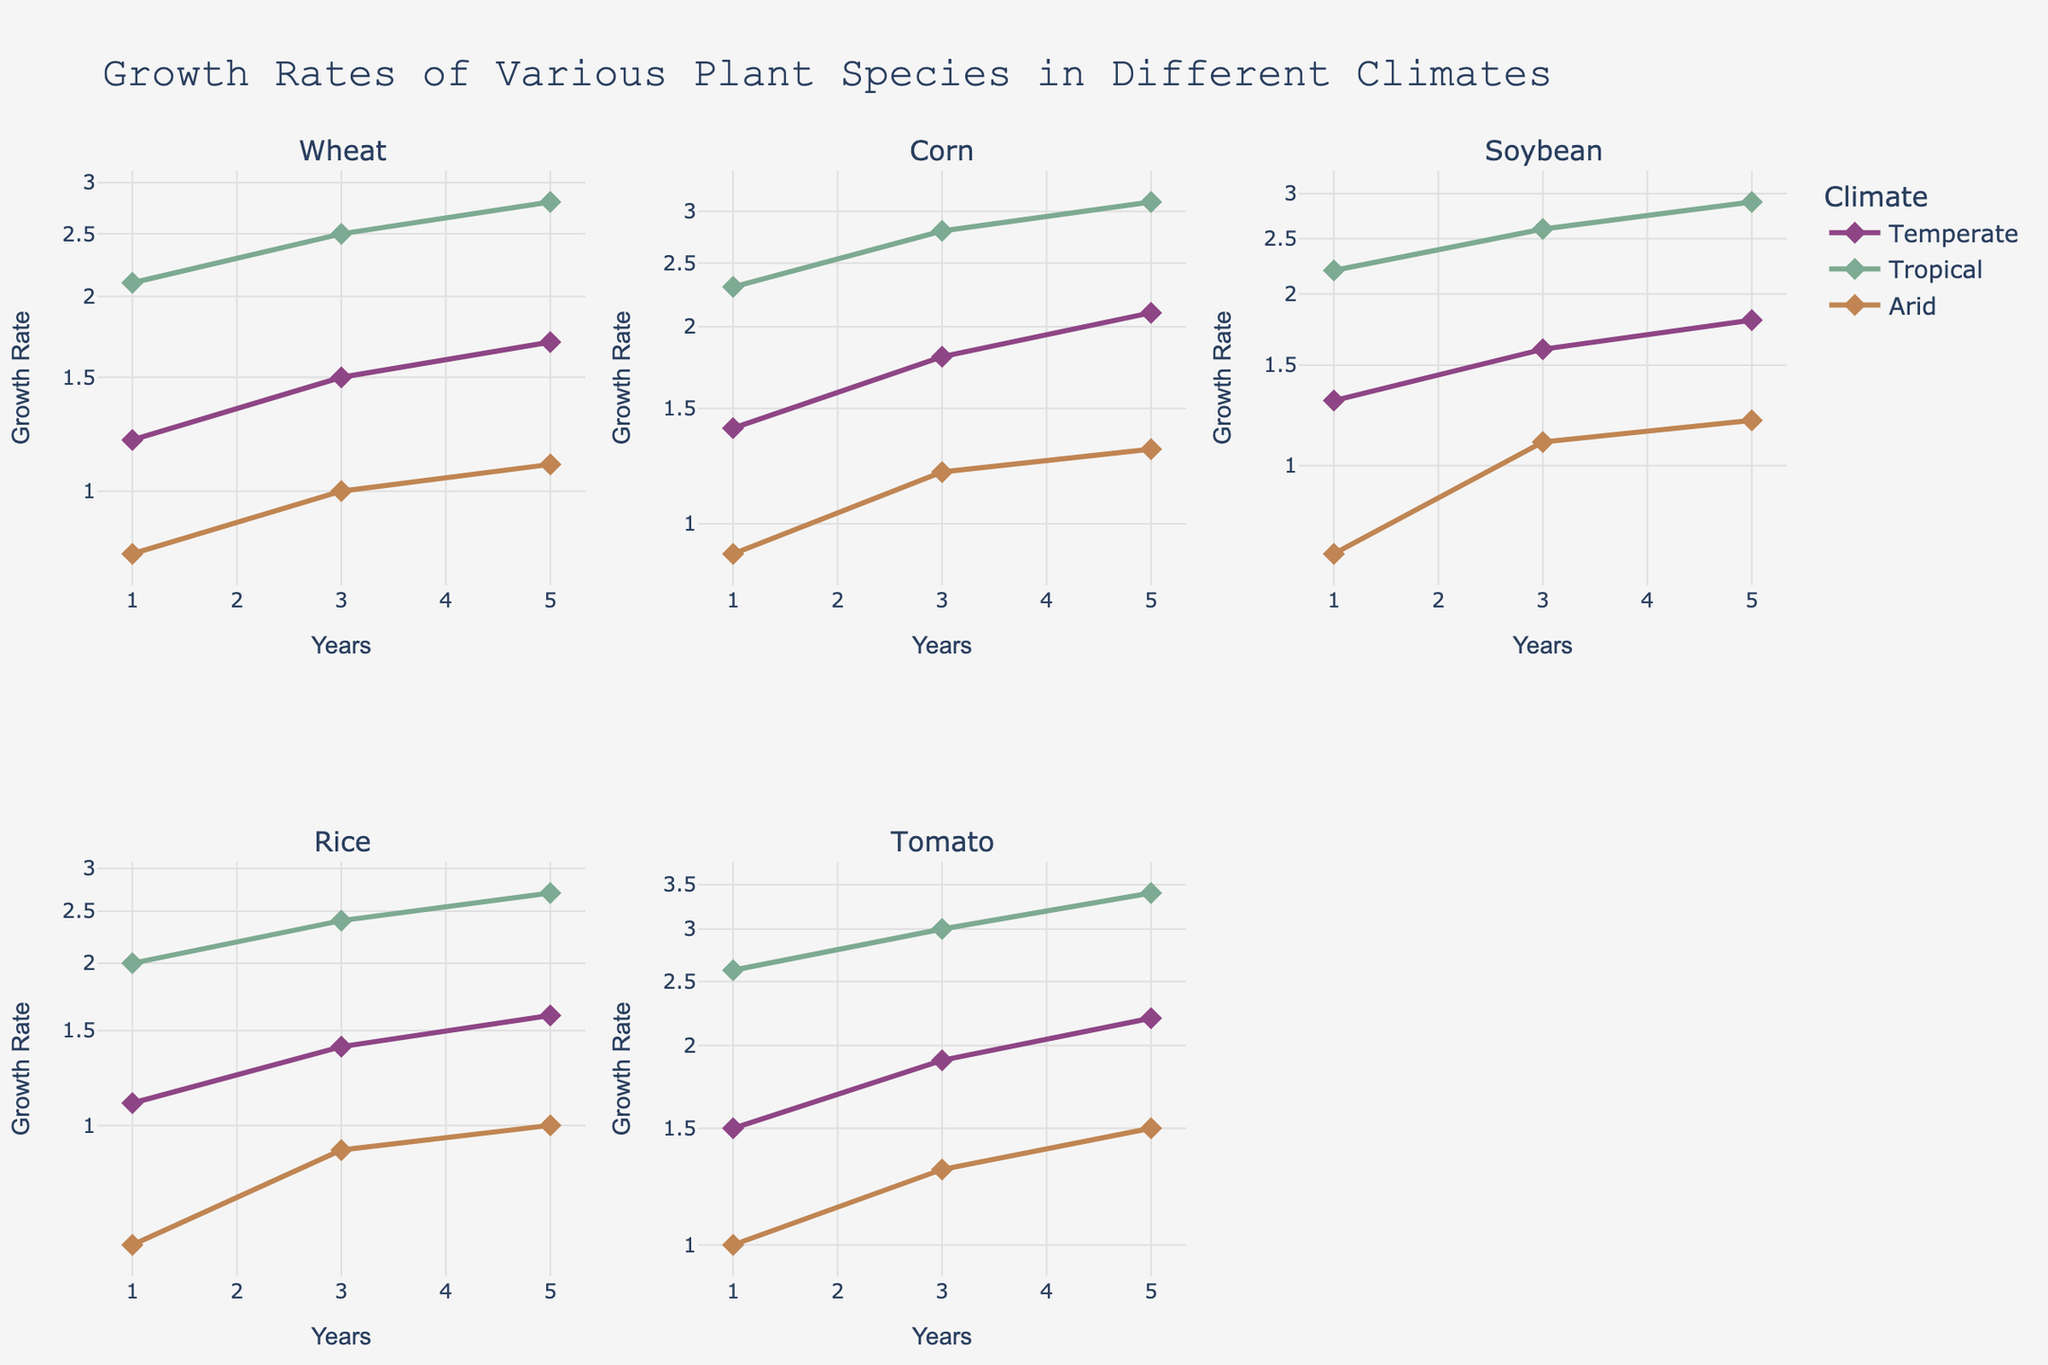What is the title of the figure? The title is usually displayed prominently at the top of the figure; it summarizes the overall content.
Answer: "Growth Rates of Various Plant Species in Different Climates" What are the types of climates represented in the figure? The legend in the figure indicates the different climates represented.
Answer: Temperate, Tropical, Arid Which plant species shows the highest growth rate in a tropical climate at year 5? Check each subplot corresponding to a plant species, look at the data points for year 5, and identify the one with the highest value, focusing on the tropical climate.
Answer: Tomato What is the difference in growth rates of Corn between the tropical and arid climates at year 3? In the subplot for Corn, note the data points for both tropical and arid climates at year 3, then subtract the arid growth rate from the tropical growth rate.
Answer: 1.6 How do the growth rates of Wheat at year 5 in temperate and arid climates compare? In the Wheat subplot, observe the year 5 data points for both temperate and arid climates and compare their values.
Answer: Temperate is higher What is the primary pattern you observe for plant species in tropical climates? Observing the subplots for each plant species, note the trend in growth rates across the years for the tropical climate.
Answer: Highest growth rates Which climate shows the lowest growth rates generally across all plants? Look at the overall trend in each subplot, focusing on the lowest values across different climates for all plants.
Answer: Arid What is the average growth rate of Rice in a temperate climate across all years? Find the growth rates for Rice in a temperate climate at years 1, 3, and 5, add them together and divide by 3.
Answer: 1.37 How does the growth rate trend of Soybean in a temperate climate compare to that in an arid climate over the years? Compare the growth rate values in the subplot for Soybean for temperate and arid climates across years 1, 3, and 5.
Answer: Temperate increases more steadily If you wanted to plant a crop from this figure in an arid climate, which would likely have the most consistent growth over 5 years? Look at the subplots and identify which plant species has the least variation in growth rates in the arid climate over 1, 3, and 5 years.
Answer: Corn 